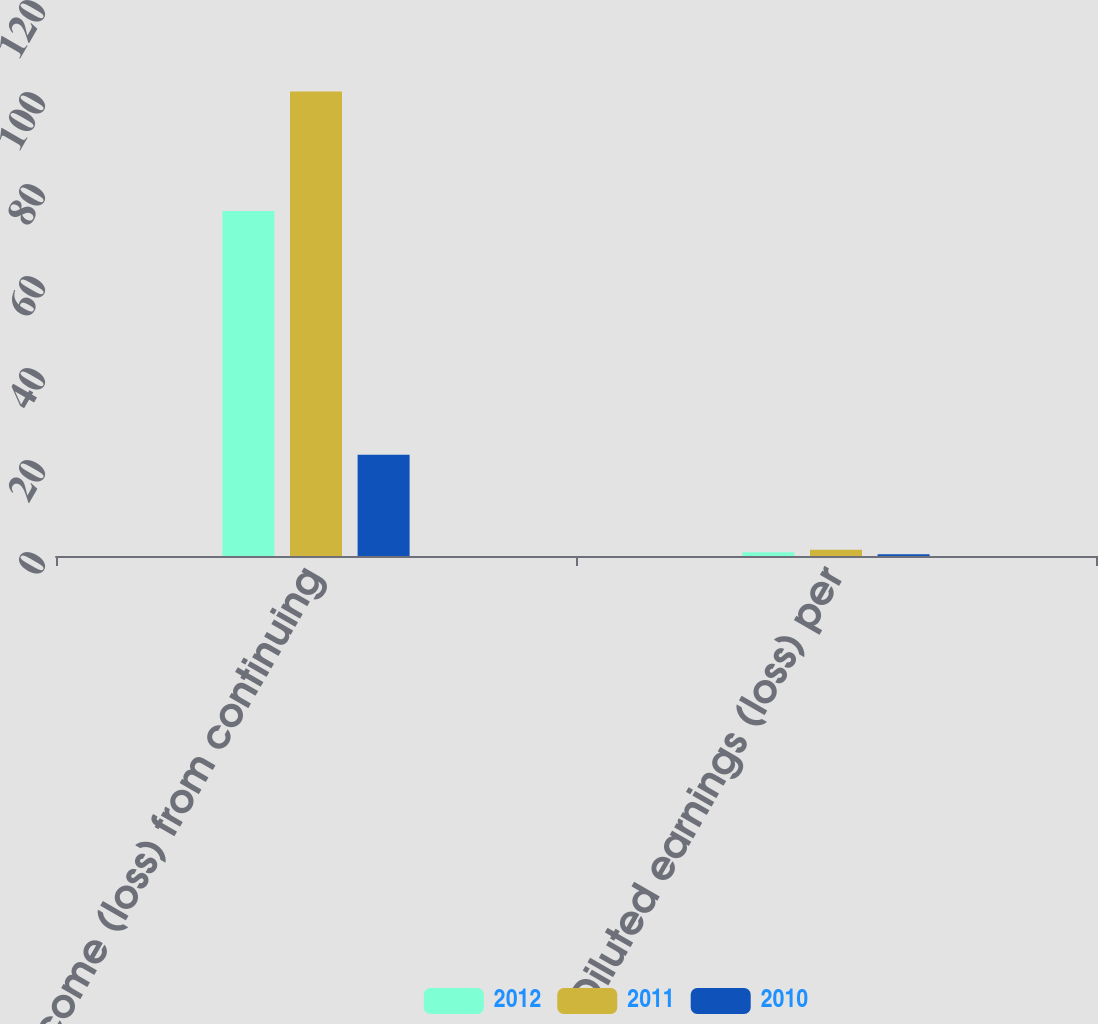Convert chart to OTSL. <chart><loc_0><loc_0><loc_500><loc_500><stacked_bar_chart><ecel><fcel>Income (loss) from continuing<fcel>Diluted earnings (loss) per<nl><fcel>2012<fcel>75<fcel>0.79<nl><fcel>2011<fcel>101<fcel>1.38<nl><fcel>2010<fcel>22<fcel>0.38<nl></chart> 